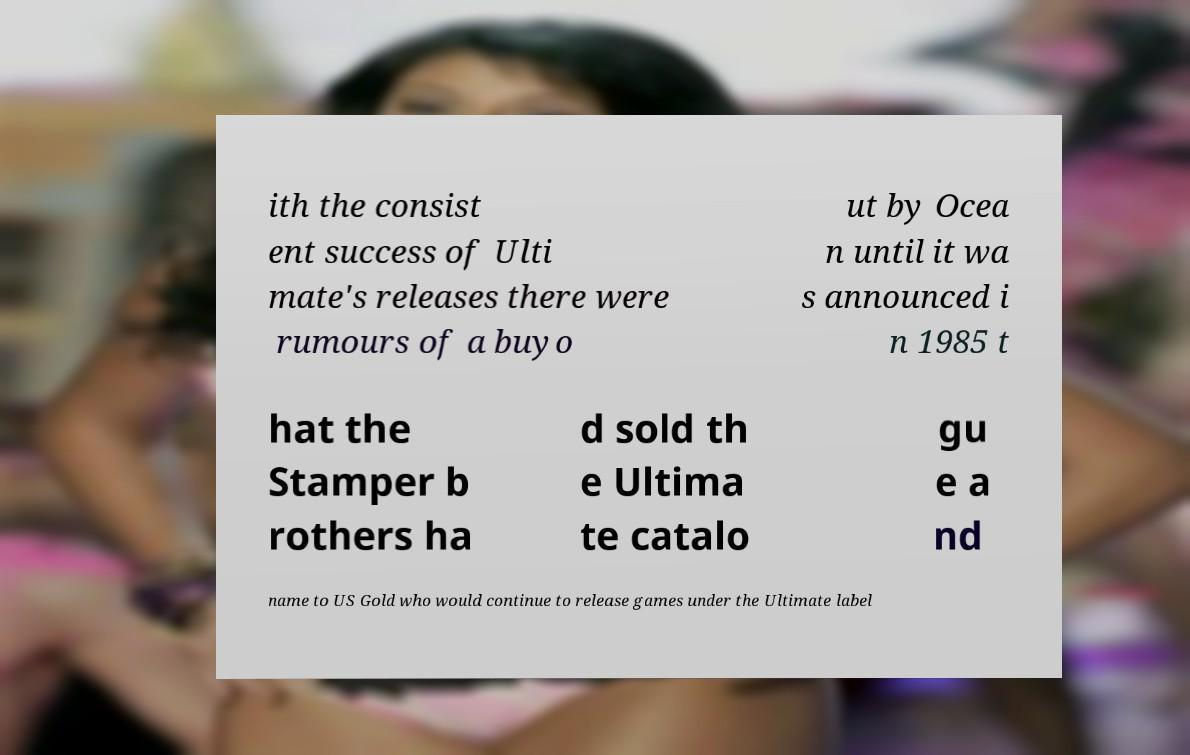Please identify and transcribe the text found in this image. ith the consist ent success of Ulti mate's releases there were rumours of a buyo ut by Ocea n until it wa s announced i n 1985 t hat the Stamper b rothers ha d sold th e Ultima te catalo gu e a nd name to US Gold who would continue to release games under the Ultimate label 